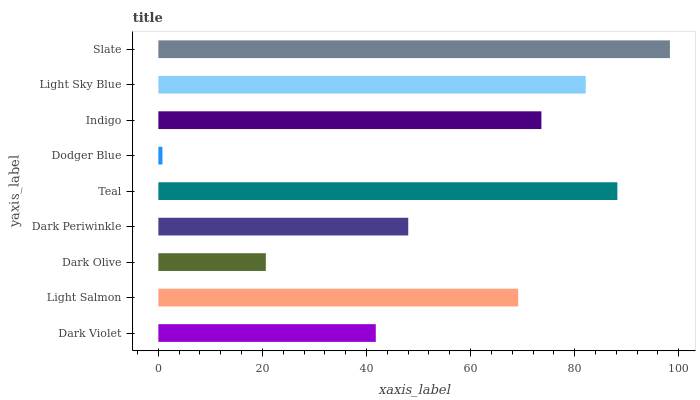Is Dodger Blue the minimum?
Answer yes or no. Yes. Is Slate the maximum?
Answer yes or no. Yes. Is Light Salmon the minimum?
Answer yes or no. No. Is Light Salmon the maximum?
Answer yes or no. No. Is Light Salmon greater than Dark Violet?
Answer yes or no. Yes. Is Dark Violet less than Light Salmon?
Answer yes or no. Yes. Is Dark Violet greater than Light Salmon?
Answer yes or no. No. Is Light Salmon less than Dark Violet?
Answer yes or no. No. Is Light Salmon the high median?
Answer yes or no. Yes. Is Light Salmon the low median?
Answer yes or no. Yes. Is Dark Violet the high median?
Answer yes or no. No. Is Teal the low median?
Answer yes or no. No. 